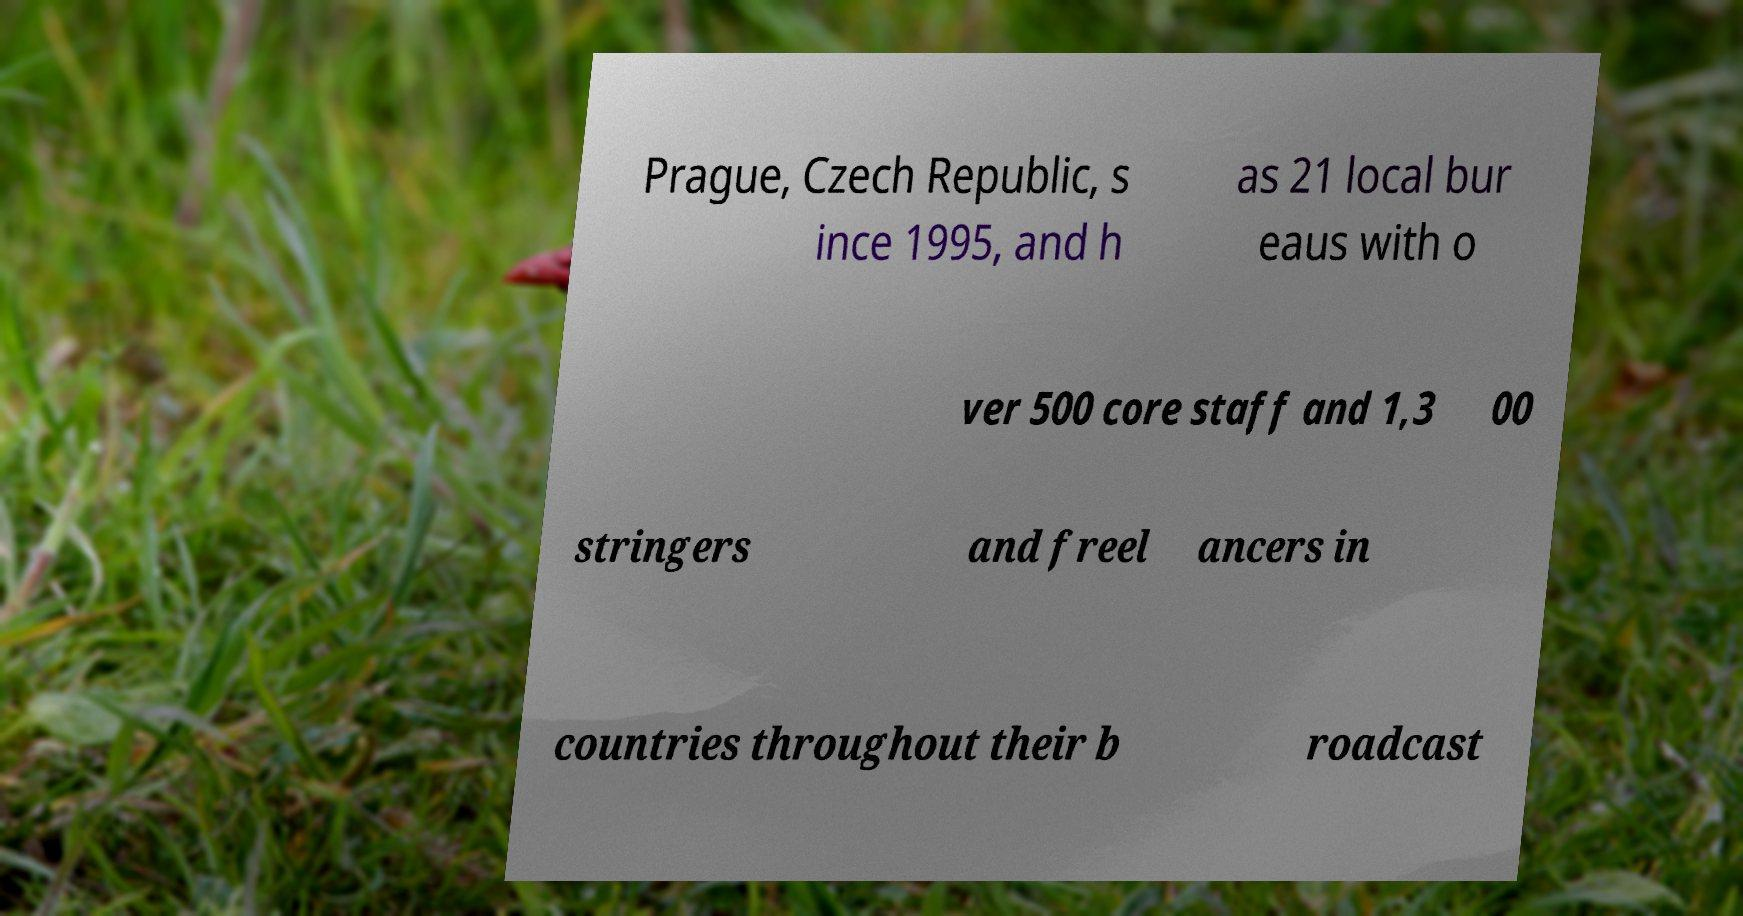Could you assist in decoding the text presented in this image and type it out clearly? Prague, Czech Republic, s ince 1995, and h as 21 local bur eaus with o ver 500 core staff and 1,3 00 stringers and freel ancers in countries throughout their b roadcast 